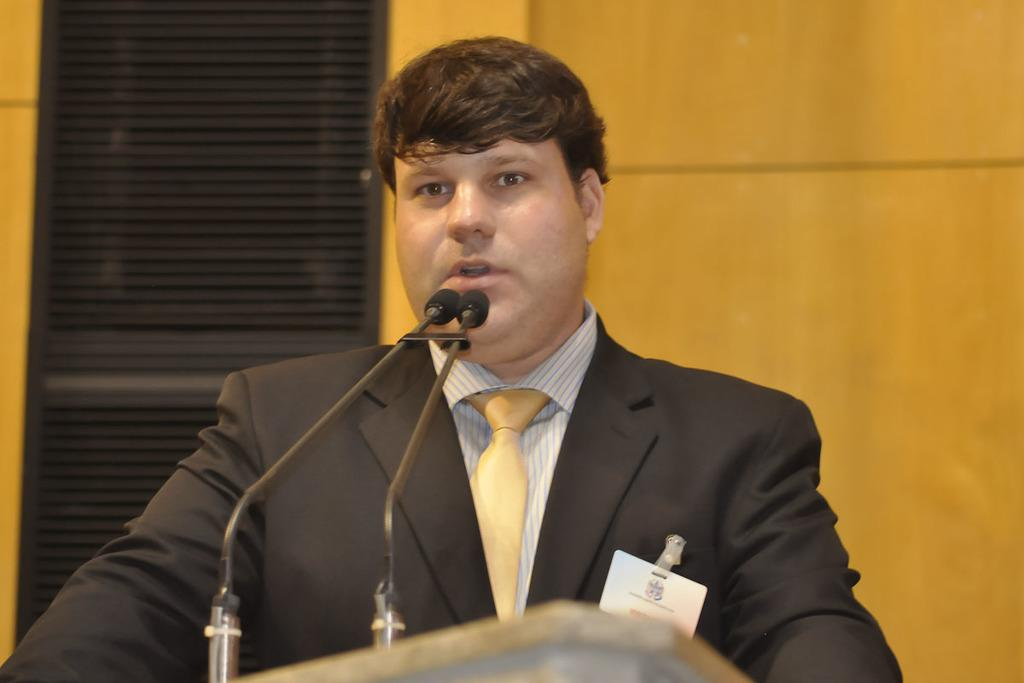What is the main subject of the image? There is a man standing in the image. What objects are visible near the man? There are microphones (mikes) in the image. What can be seen in the background of the image? There is a wall in the background of the image. What might the man be using the microphones for? The presence of microphones and a podium at the bottom of the image suggests that the man might be giving a speech or presentation. Can you see any ducks in the image? There are no ducks present in the image. What is the man's level of fear in the image? The image does not provide any information about the man's emotions or feelings, including fear. 